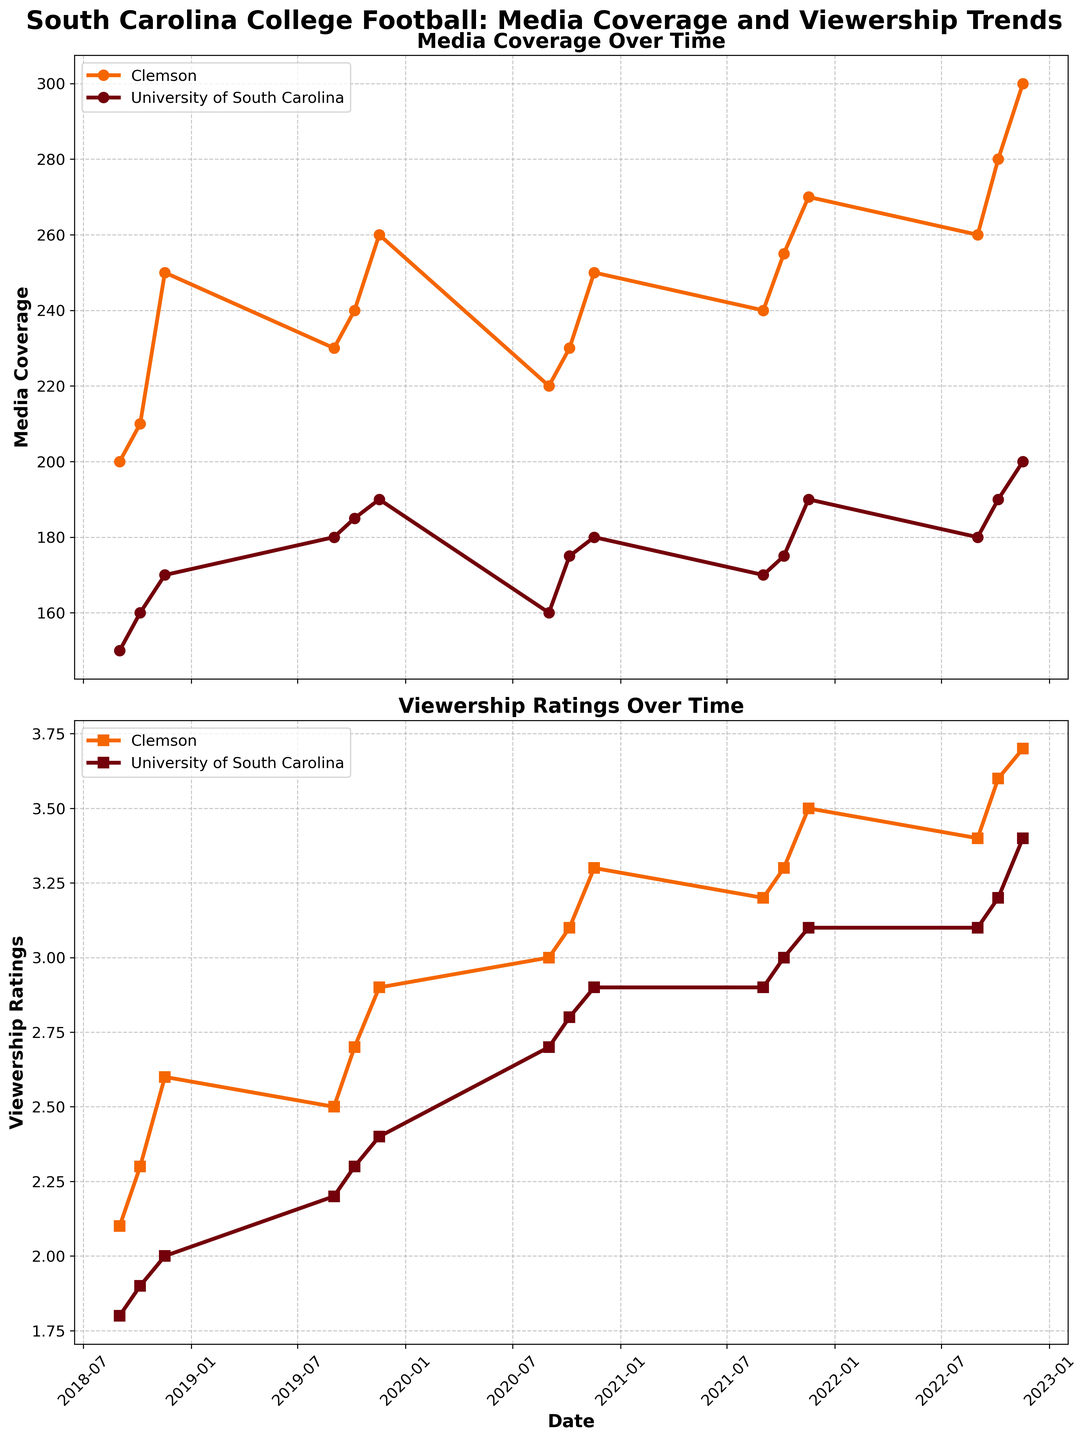What is the title of the figure? The title is usually located at the top of the figure. Here, it reads "South Carolina College Football: Media Coverage and Viewership Trends".
Answer: South Carolina College Football: Media Coverage and Viewership Trends What are the colors used to represent Clemson and the University of South Carolina? The colors are shown in the legend at the bottom of each plot. Clemson is represented by orange, and the University of South Carolina is represented by garnet (dark red).
Answer: Orange for Clemson, Garnet for the University of South Carolina Which university had higher media coverage on November 17, 2019? Locate the data points for November 17, 2019, for both universities in the Media Coverage plot. Compare the values of the two data points. Clemson's media coverage is 260, while the University of South Carolina's media coverage is 190.
Answer: Clemson On which date did both universities have the same viewership rating? Look at the viewership plot and identify if there is any date where the data points for Clemson and the University of South Carolina overlap. On September 1, 2020, both universities had the same viewership rating of 2.7.
Answer: September 1, 2020 By how much did Clemson's media coverage increase from September 1, 2021, to November 17, 2022? Observe the media coverage for Clemson on both dates. On September 1, 2021, coverage was 240. On November 17, 2022, it was 300. The increase is 300 - 240 = 60.
Answer: 60 Which university had a more significant increase in viewership ratings from November 17, 2018, to November 17, 2022? Calculate the difference in viewership ratings for both universities on these dates. Clemson's viewership increased from 2.6 to 3.7, an increase of 1.1. The University of South Carolina's viewership increased from 2.0 to 3.4, an increase of 1.4. Compare the increases.
Answer: University of South Carolina What is the average viewership rating for the University of South Carolina in the years 2021 and 2022? Sum the viewership ratings for the University of South Carolina in 2021 and 2022, then divide by the number of data points. (2.9 + 3.0 + 3.1 + 3.2 + 3.2 + 3.4) / 6 = 18.8 / 6 ≈ 3.13.
Answer: 3.13 On which date did Clemson's viewership rating first reach 3.0 or higher? Find the first instance in the viewership plot where Clemson's viewership rating is 3.0 or higher. The earliest date is September 1, 2020, with a rating of 3.0.
Answer: September 1, 2020 Which university generally had higher media coverage across the entire time period? Observe the overall trend in the media coverage plot for both universities. Clemson's media coverage is consistently higher than the University of South Carolina.
Answer: Clemson How many distinct dates are there when the data was recorded in the provided plots? Count the number of unique dates along the x-axis of the plots. There are eight distinct dates observed.
Answer: Eight 